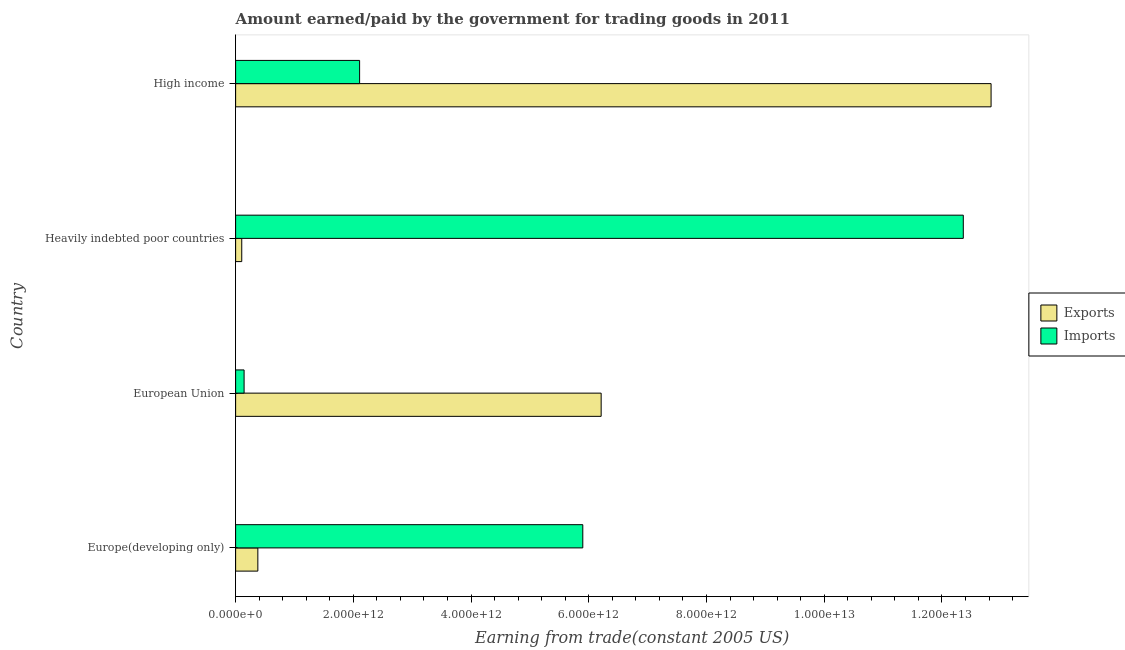How many groups of bars are there?
Provide a succinct answer. 4. Are the number of bars per tick equal to the number of legend labels?
Keep it short and to the point. Yes. How many bars are there on the 4th tick from the bottom?
Make the answer very short. 2. In how many cases, is the number of bars for a given country not equal to the number of legend labels?
Offer a terse response. 0. What is the amount earned from exports in Heavily indebted poor countries?
Offer a terse response. 1.04e+11. Across all countries, what is the maximum amount paid for imports?
Your answer should be very brief. 1.24e+13. Across all countries, what is the minimum amount earned from exports?
Give a very brief answer. 1.04e+11. In which country was the amount paid for imports maximum?
Keep it short and to the point. Heavily indebted poor countries. In which country was the amount paid for imports minimum?
Give a very brief answer. European Union. What is the total amount earned from exports in the graph?
Make the answer very short. 1.95e+13. What is the difference between the amount earned from exports in Europe(developing only) and that in High income?
Offer a very short reply. -1.25e+13. What is the difference between the amount paid for imports in Europe(developing only) and the amount earned from exports in Heavily indebted poor countries?
Offer a very short reply. 5.79e+12. What is the average amount paid for imports per country?
Make the answer very short. 5.13e+12. What is the difference between the amount paid for imports and amount earned from exports in Europe(developing only)?
Your answer should be compact. 5.52e+12. In how many countries, is the amount earned from exports greater than 9200000000000 US$?
Offer a terse response. 1. What is the ratio of the amount earned from exports in Europe(developing only) to that in High income?
Your answer should be very brief. 0.03. Is the difference between the amount earned from exports in Europe(developing only) and High income greater than the difference between the amount paid for imports in Europe(developing only) and High income?
Your response must be concise. No. What is the difference between the highest and the second highest amount earned from exports?
Offer a very short reply. 6.62e+12. What is the difference between the highest and the lowest amount paid for imports?
Your answer should be very brief. 1.22e+13. Is the sum of the amount earned from exports in Europe(developing only) and European Union greater than the maximum amount paid for imports across all countries?
Ensure brevity in your answer.  No. What does the 2nd bar from the top in Heavily indebted poor countries represents?
Offer a terse response. Exports. What does the 1st bar from the bottom in High income represents?
Your answer should be compact. Exports. How many countries are there in the graph?
Provide a succinct answer. 4. What is the difference between two consecutive major ticks on the X-axis?
Your answer should be compact. 2.00e+12. Does the graph contain any zero values?
Your answer should be compact. No. Does the graph contain grids?
Provide a succinct answer. No. How many legend labels are there?
Offer a terse response. 2. How are the legend labels stacked?
Your answer should be very brief. Vertical. What is the title of the graph?
Ensure brevity in your answer.  Amount earned/paid by the government for trading goods in 2011. What is the label or title of the X-axis?
Your response must be concise. Earning from trade(constant 2005 US). What is the label or title of the Y-axis?
Your answer should be compact. Country. What is the Earning from trade(constant 2005 US) of Exports in Europe(developing only)?
Keep it short and to the point. 3.78e+11. What is the Earning from trade(constant 2005 US) in Imports in Europe(developing only)?
Keep it short and to the point. 5.90e+12. What is the Earning from trade(constant 2005 US) of Exports in European Union?
Offer a terse response. 6.21e+12. What is the Earning from trade(constant 2005 US) in Imports in European Union?
Make the answer very short. 1.44e+11. What is the Earning from trade(constant 2005 US) in Exports in Heavily indebted poor countries?
Make the answer very short. 1.04e+11. What is the Earning from trade(constant 2005 US) in Imports in Heavily indebted poor countries?
Offer a very short reply. 1.24e+13. What is the Earning from trade(constant 2005 US) of Exports in High income?
Your answer should be very brief. 1.28e+13. What is the Earning from trade(constant 2005 US) of Imports in High income?
Offer a terse response. 2.11e+12. Across all countries, what is the maximum Earning from trade(constant 2005 US) of Exports?
Ensure brevity in your answer.  1.28e+13. Across all countries, what is the maximum Earning from trade(constant 2005 US) in Imports?
Your answer should be very brief. 1.24e+13. Across all countries, what is the minimum Earning from trade(constant 2005 US) of Exports?
Your answer should be compact. 1.04e+11. Across all countries, what is the minimum Earning from trade(constant 2005 US) of Imports?
Ensure brevity in your answer.  1.44e+11. What is the total Earning from trade(constant 2005 US) of Exports in the graph?
Make the answer very short. 1.95e+13. What is the total Earning from trade(constant 2005 US) of Imports in the graph?
Your response must be concise. 2.05e+13. What is the difference between the Earning from trade(constant 2005 US) of Exports in Europe(developing only) and that in European Union?
Keep it short and to the point. -5.83e+12. What is the difference between the Earning from trade(constant 2005 US) of Imports in Europe(developing only) and that in European Union?
Your response must be concise. 5.75e+12. What is the difference between the Earning from trade(constant 2005 US) of Exports in Europe(developing only) and that in Heavily indebted poor countries?
Provide a short and direct response. 2.73e+11. What is the difference between the Earning from trade(constant 2005 US) in Imports in Europe(developing only) and that in Heavily indebted poor countries?
Your answer should be very brief. -6.46e+12. What is the difference between the Earning from trade(constant 2005 US) in Exports in Europe(developing only) and that in High income?
Offer a very short reply. -1.25e+13. What is the difference between the Earning from trade(constant 2005 US) in Imports in Europe(developing only) and that in High income?
Offer a terse response. 3.79e+12. What is the difference between the Earning from trade(constant 2005 US) of Exports in European Union and that in Heavily indebted poor countries?
Your response must be concise. 6.11e+12. What is the difference between the Earning from trade(constant 2005 US) of Imports in European Union and that in Heavily indebted poor countries?
Give a very brief answer. -1.22e+13. What is the difference between the Earning from trade(constant 2005 US) of Exports in European Union and that in High income?
Your response must be concise. -6.62e+12. What is the difference between the Earning from trade(constant 2005 US) of Imports in European Union and that in High income?
Ensure brevity in your answer.  -1.96e+12. What is the difference between the Earning from trade(constant 2005 US) of Exports in Heavily indebted poor countries and that in High income?
Your answer should be very brief. -1.27e+13. What is the difference between the Earning from trade(constant 2005 US) of Imports in Heavily indebted poor countries and that in High income?
Your answer should be compact. 1.03e+13. What is the difference between the Earning from trade(constant 2005 US) of Exports in Europe(developing only) and the Earning from trade(constant 2005 US) of Imports in European Union?
Offer a very short reply. 2.34e+11. What is the difference between the Earning from trade(constant 2005 US) in Exports in Europe(developing only) and the Earning from trade(constant 2005 US) in Imports in Heavily indebted poor countries?
Provide a short and direct response. -1.20e+13. What is the difference between the Earning from trade(constant 2005 US) of Exports in Europe(developing only) and the Earning from trade(constant 2005 US) of Imports in High income?
Make the answer very short. -1.73e+12. What is the difference between the Earning from trade(constant 2005 US) in Exports in European Union and the Earning from trade(constant 2005 US) in Imports in Heavily indebted poor countries?
Your response must be concise. -6.15e+12. What is the difference between the Earning from trade(constant 2005 US) in Exports in European Union and the Earning from trade(constant 2005 US) in Imports in High income?
Ensure brevity in your answer.  4.10e+12. What is the difference between the Earning from trade(constant 2005 US) of Exports in Heavily indebted poor countries and the Earning from trade(constant 2005 US) of Imports in High income?
Your response must be concise. -2.00e+12. What is the average Earning from trade(constant 2005 US) in Exports per country?
Your answer should be very brief. 4.88e+12. What is the average Earning from trade(constant 2005 US) in Imports per country?
Offer a terse response. 5.13e+12. What is the difference between the Earning from trade(constant 2005 US) in Exports and Earning from trade(constant 2005 US) in Imports in Europe(developing only)?
Provide a short and direct response. -5.52e+12. What is the difference between the Earning from trade(constant 2005 US) of Exports and Earning from trade(constant 2005 US) of Imports in European Union?
Ensure brevity in your answer.  6.07e+12. What is the difference between the Earning from trade(constant 2005 US) in Exports and Earning from trade(constant 2005 US) in Imports in Heavily indebted poor countries?
Offer a terse response. -1.23e+13. What is the difference between the Earning from trade(constant 2005 US) of Exports and Earning from trade(constant 2005 US) of Imports in High income?
Ensure brevity in your answer.  1.07e+13. What is the ratio of the Earning from trade(constant 2005 US) of Exports in Europe(developing only) to that in European Union?
Your answer should be very brief. 0.06. What is the ratio of the Earning from trade(constant 2005 US) in Imports in Europe(developing only) to that in European Union?
Your response must be concise. 40.96. What is the ratio of the Earning from trade(constant 2005 US) of Exports in Europe(developing only) to that in Heavily indebted poor countries?
Ensure brevity in your answer.  3.62. What is the ratio of the Earning from trade(constant 2005 US) in Imports in Europe(developing only) to that in Heavily indebted poor countries?
Provide a succinct answer. 0.48. What is the ratio of the Earning from trade(constant 2005 US) of Exports in Europe(developing only) to that in High income?
Ensure brevity in your answer.  0.03. What is the ratio of the Earning from trade(constant 2005 US) in Exports in European Union to that in Heavily indebted poor countries?
Offer a very short reply. 59.55. What is the ratio of the Earning from trade(constant 2005 US) of Imports in European Union to that in Heavily indebted poor countries?
Keep it short and to the point. 0.01. What is the ratio of the Earning from trade(constant 2005 US) of Exports in European Union to that in High income?
Give a very brief answer. 0.48. What is the ratio of the Earning from trade(constant 2005 US) in Imports in European Union to that in High income?
Make the answer very short. 0.07. What is the ratio of the Earning from trade(constant 2005 US) in Exports in Heavily indebted poor countries to that in High income?
Give a very brief answer. 0.01. What is the ratio of the Earning from trade(constant 2005 US) in Imports in Heavily indebted poor countries to that in High income?
Keep it short and to the point. 5.87. What is the difference between the highest and the second highest Earning from trade(constant 2005 US) in Exports?
Your response must be concise. 6.62e+12. What is the difference between the highest and the second highest Earning from trade(constant 2005 US) of Imports?
Your answer should be compact. 6.46e+12. What is the difference between the highest and the lowest Earning from trade(constant 2005 US) of Exports?
Your answer should be very brief. 1.27e+13. What is the difference between the highest and the lowest Earning from trade(constant 2005 US) of Imports?
Provide a short and direct response. 1.22e+13. 